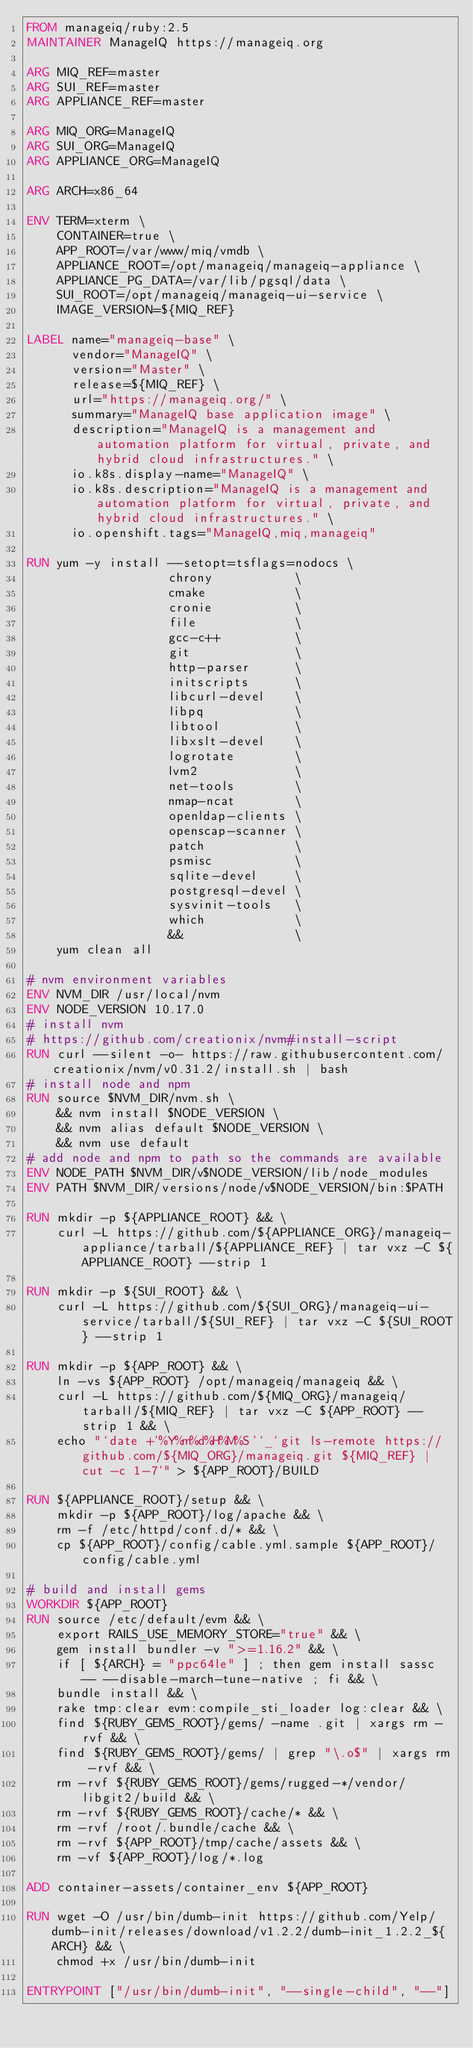Convert code to text. <code><loc_0><loc_0><loc_500><loc_500><_Dockerfile_>FROM manageiq/ruby:2.5
MAINTAINER ManageIQ https://manageiq.org

ARG MIQ_REF=master
ARG SUI_REF=master
ARG APPLIANCE_REF=master

ARG MIQ_ORG=ManageIQ
ARG SUI_ORG=ManageIQ
ARG APPLIANCE_ORG=ManageIQ

ARG ARCH=x86_64

ENV TERM=xterm \
    CONTAINER=true \
    APP_ROOT=/var/www/miq/vmdb \
    APPLIANCE_ROOT=/opt/manageiq/manageiq-appliance \
    APPLIANCE_PG_DATA=/var/lib/pgsql/data \
    SUI_ROOT=/opt/manageiq/manageiq-ui-service \
    IMAGE_VERSION=${MIQ_REF}

LABEL name="manageiq-base" \
      vendor="ManageIQ" \
      version="Master" \
      release=${MIQ_REF} \
      url="https://manageiq.org/" \
      summary="ManageIQ base application image" \
      description="ManageIQ is a management and automation platform for virtual, private, and hybrid cloud infrastructures." \
      io.k8s.display-name="ManageIQ" \
      io.k8s.description="ManageIQ is a management and automation platform for virtual, private, and hybrid cloud infrastructures." \
      io.openshift.tags="ManageIQ,miq,manageiq"

RUN yum -y install --setopt=tsflags=nodocs \
                   chrony           \
                   cmake            \
                   cronie           \
                   file             \
                   gcc-c++          \
                   git              \
                   http-parser      \
                   initscripts      \
                   libcurl-devel    \
                   libpq            \
                   libtool          \
                   libxslt-devel    \
                   logrotate        \
                   lvm2             \
                   net-tools        \
                   nmap-ncat        \
                   openldap-clients \
                   openscap-scanner \
                   patch            \
                   psmisc           \
                   sqlite-devel     \
                   postgresql-devel \
                   sysvinit-tools   \
                   which            \
                   &&               \
    yum clean all

# nvm environment variables
ENV NVM_DIR /usr/local/nvm
ENV NODE_VERSION 10.17.0
# install nvm
# https://github.com/creationix/nvm#install-script
RUN curl --silent -o- https://raw.githubusercontent.com/creationix/nvm/v0.31.2/install.sh | bash
# install node and npm
RUN source $NVM_DIR/nvm.sh \
    && nvm install $NODE_VERSION \
    && nvm alias default $NODE_VERSION \
    && nvm use default
# add node and npm to path so the commands are available
ENV NODE_PATH $NVM_DIR/v$NODE_VERSION/lib/node_modules
ENV PATH $NVM_DIR/versions/node/v$NODE_VERSION/bin:$PATH

RUN mkdir -p ${APPLIANCE_ROOT} && \
    curl -L https://github.com/${APPLIANCE_ORG}/manageiq-appliance/tarball/${APPLIANCE_REF} | tar vxz -C ${APPLIANCE_ROOT} --strip 1

RUN mkdir -p ${SUI_ROOT} && \
    curl -L https://github.com/${SUI_ORG}/manageiq-ui-service/tarball/${SUI_REF} | tar vxz -C ${SUI_ROOT} --strip 1

RUN mkdir -p ${APP_ROOT} && \
    ln -vs ${APP_ROOT} /opt/manageiq/manageiq && \
    curl -L https://github.com/${MIQ_ORG}/manageiq/tarball/${MIQ_REF} | tar vxz -C ${APP_ROOT} --strip 1 && \
    echo "`date +'%Y%m%d%H%M%S'`_`git ls-remote https://github.com/${MIQ_ORG}/manageiq.git ${MIQ_REF} | cut -c 1-7`" > ${APP_ROOT}/BUILD

RUN ${APPLIANCE_ROOT}/setup && \
    mkdir -p ${APP_ROOT}/log/apache && \
    rm -f /etc/httpd/conf.d/* && \
    cp ${APP_ROOT}/config/cable.yml.sample ${APP_ROOT}/config/cable.yml

# build and install gems
WORKDIR ${APP_ROOT}
RUN source /etc/default/evm && \
    export RAILS_USE_MEMORY_STORE="true" && \
    gem install bundler -v ">=1.16.2" && \
    if [ ${ARCH} = "ppc64le" ] ; then gem install sassc  -- --disable-march-tune-native ; fi && \
    bundle install && \
    rake tmp:clear evm:compile_sti_loader log:clear && \
    find ${RUBY_GEMS_ROOT}/gems/ -name .git | xargs rm -rvf && \
    find ${RUBY_GEMS_ROOT}/gems/ | grep "\.o$" | xargs rm -rvf && \
    rm -rvf ${RUBY_GEMS_ROOT}/gems/rugged-*/vendor/libgit2/build && \
    rm -rvf ${RUBY_GEMS_ROOT}/cache/* && \
    rm -rvf /root/.bundle/cache && \
    rm -rvf ${APP_ROOT}/tmp/cache/assets && \
    rm -vf ${APP_ROOT}/log/*.log

ADD container-assets/container_env ${APP_ROOT}

RUN wget -O /usr/bin/dumb-init https://github.com/Yelp/dumb-init/releases/download/v1.2.2/dumb-init_1.2.2_${ARCH} && \
    chmod +x /usr/bin/dumb-init

ENTRYPOINT ["/usr/bin/dumb-init", "--single-child", "--"]
</code> 